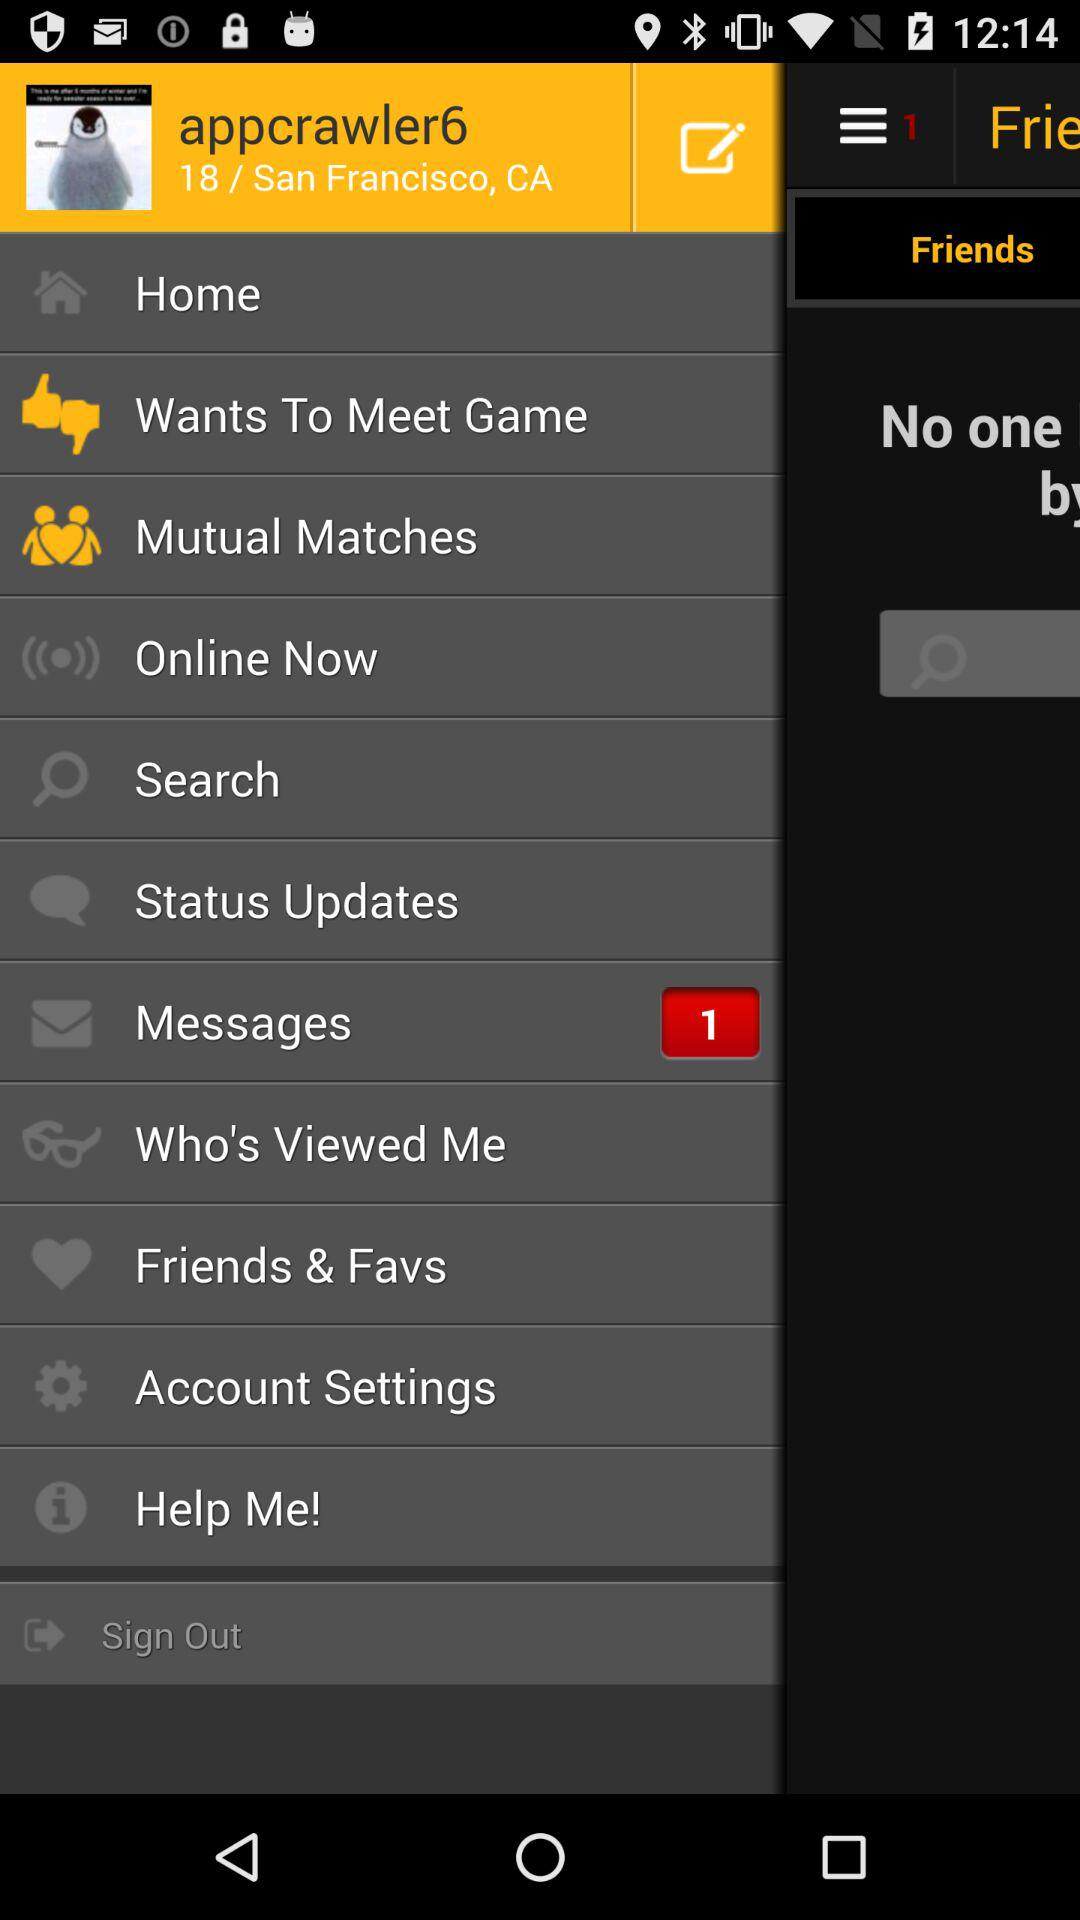What is the location? The location is San Francisco, CA. 